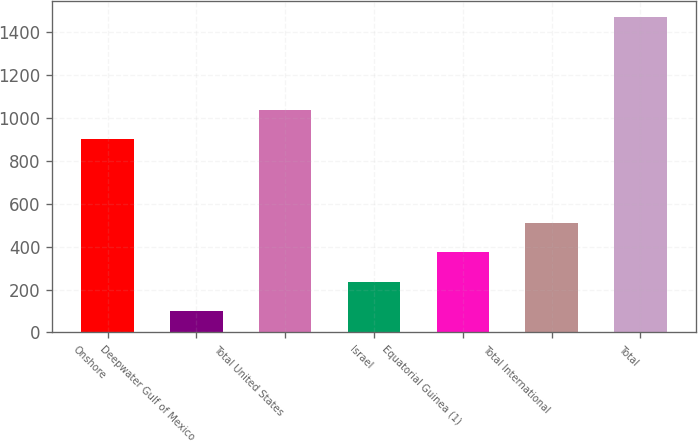Convert chart to OTSL. <chart><loc_0><loc_0><loc_500><loc_500><bar_chart><fcel>Onshore<fcel>Deepwater Gulf of Mexico<fcel>Total United States<fcel>Israel<fcel>Equatorial Guinea (1)<fcel>Total International<fcel>Total<nl><fcel>902<fcel>100<fcel>1039.3<fcel>237.3<fcel>374.6<fcel>511.9<fcel>1473<nl></chart> 